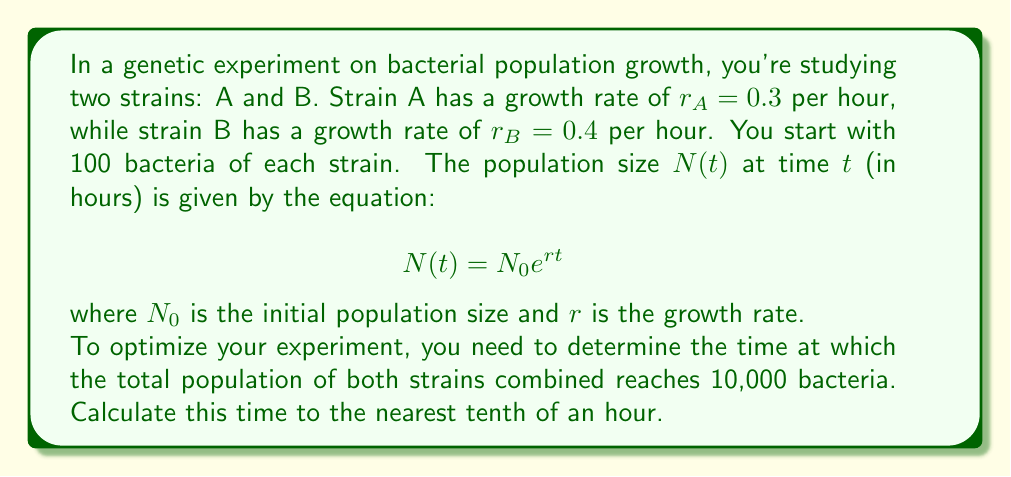Solve this math problem. Let's approach this step-by-step:

1) We have two separate populations growing simultaneously. Let's call them $N_A(t)$ and $N_B(t)$.

2) For strain A:
   $N_A(t) = 100 e^{0.3t}$

3) For strain B:
   $N_B(t) = 100 e^{0.4t}$

4) We want to find $t$ when $N_A(t) + N_B(t) = 10,000$

5) Let's set up the equation:
   $100 e^{0.3t} + 100 e^{0.4t} = 10,000$

6) Divide both sides by 100:
   $e^{0.3t} + e^{0.4t} = 100$

7) This equation can't be solved algebraically. We need to use numerical methods or graphing to find the solution.

8) Using a graphing calculator or computer software, we can plot the function:
   $f(t) = e^{0.3t} + e^{0.4t} - 100$

9) The solution is the t-value where this function crosses the x-axis.

10) Using such methods, we find that the solution is approximately 11.8 hours.

11) Rounding to the nearest tenth of an hour gives us 11.8 hours.
Answer: 11.8 hours 